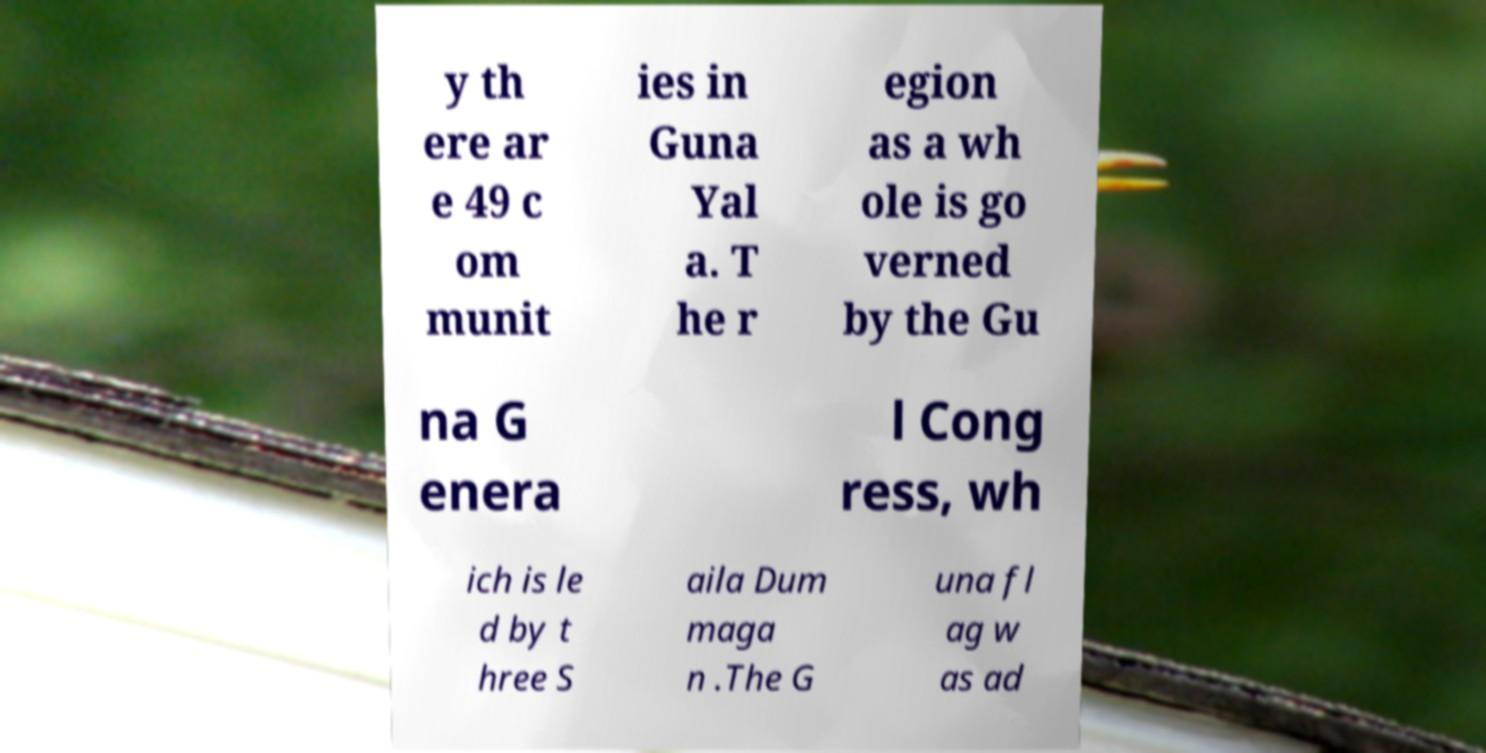What messages or text are displayed in this image? I need them in a readable, typed format. y th ere ar e 49 c om munit ies in Guna Yal a. T he r egion as a wh ole is go verned by the Gu na G enera l Cong ress, wh ich is le d by t hree S aila Dum maga n .The G una fl ag w as ad 